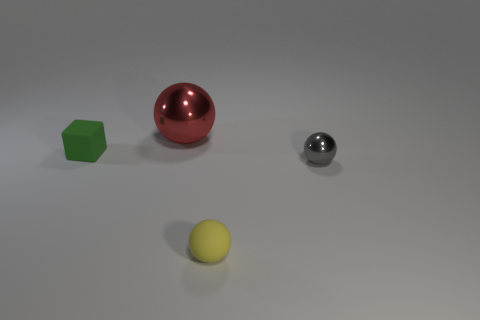Are there any other things that are the same size as the red thing?
Keep it short and to the point. No. There is a small rubber object on the right side of the metal ball behind the small block; what is its color?
Provide a succinct answer. Yellow. Are there any yellow rubber things that are on the left side of the tiny sphere to the left of the small ball that is on the right side of the yellow object?
Give a very brief answer. No. What is the color of the thing that is made of the same material as the tiny cube?
Keep it short and to the point. Yellow. What number of tiny green objects are the same material as the gray thing?
Offer a terse response. 0. Are the big red sphere and the tiny yellow sphere that is in front of the small green matte object made of the same material?
Offer a terse response. No. What number of objects are spheres to the right of the red metallic thing or big purple matte cubes?
Offer a very short reply. 2. There is a metallic ball behind the matte object that is left of the sphere that is behind the small gray metal sphere; what size is it?
Make the answer very short. Large. Is there any other thing that is the same shape as the red shiny thing?
Your answer should be compact. Yes. There is a shiny ball that is on the right side of the rubber object right of the green rubber object; what is its size?
Your response must be concise. Small. 